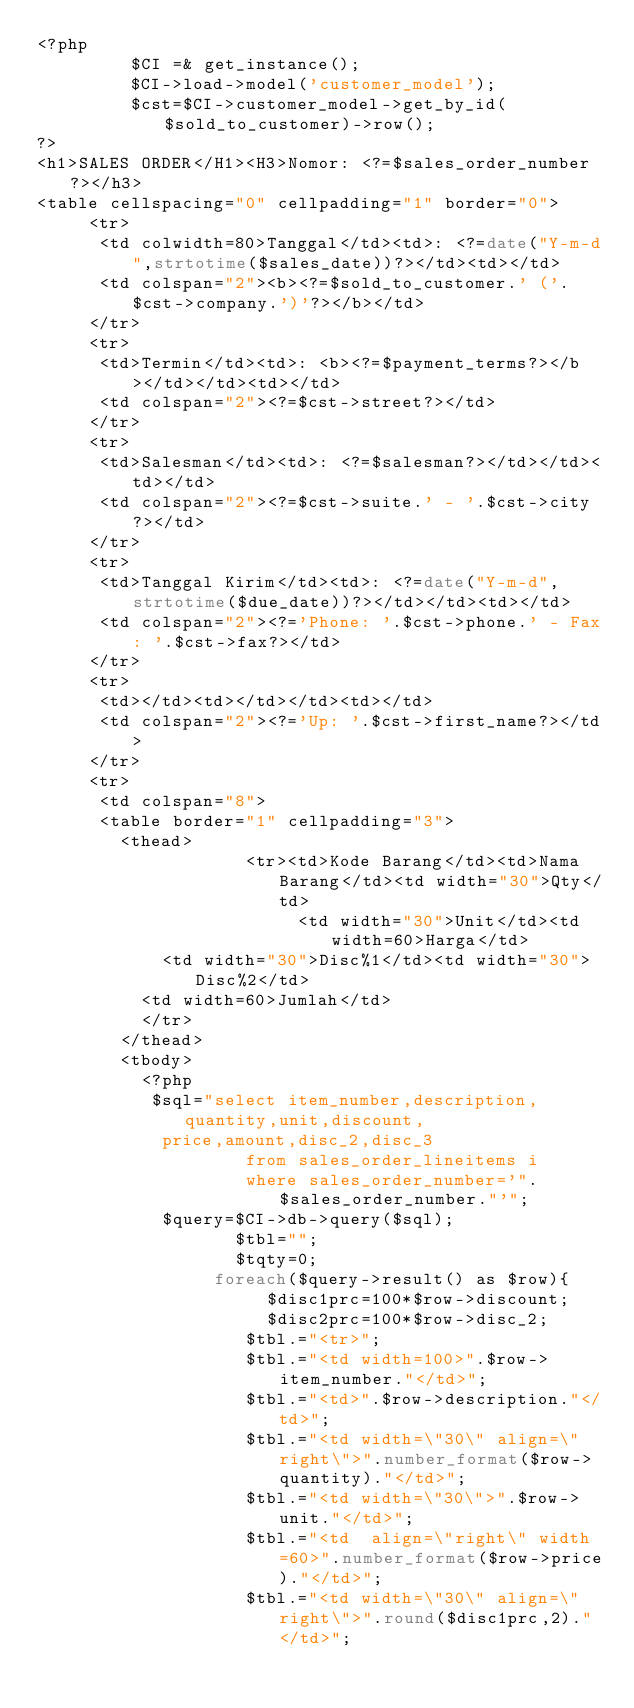Convert code to text. <code><loc_0><loc_0><loc_500><loc_500><_PHP_><?php
         $CI =& get_instance();
         $CI->load->model('customer_model');
         $cst=$CI->customer_model->get_by_id($sold_to_customer)->row();
?>
<h1>SALES ORDER</H1><H3>Nomor: <?=$sales_order_number?></h3>
<table cellspacing="0" cellpadding="1" border="0"> 
     <tr>
     	<td colwidth=80>Tanggal</td><td>: <?=date("Y-m-d",strtotime($sales_date))?></td><td></td>
     	<td colspan="2"><b><?=$sold_to_customer.' ('.$cst->company.')'?></b></td>
     </tr>
     <tr>
     	<td>Termin</td><td>: <b><?=$payment_terms?></b></td></td><td></td>
     	<td colspan="2"><?=$cst->street?></td>
     </tr>
     <tr>
     	<td>Salesman</td><td>: <?=$salesman?></td></td><td></td>
     	<td colspan="2"><?=$cst->suite.' - '.$cst->city?></td>
     </tr>
     <tr>
     	<td>Tanggal Kirim</td><td>: <?=date("Y-m-d",strtotime($due_date))?></td></td><td></td>
     	<td colspan="2"><?='Phone: '.$cst->phone.' - Fax: '.$cst->fax?></td>
     </tr>
     <tr>
     	<td></td><td></td></td><td></td>
     	<td colspan="2"><?='Up: '.$cst->first_name?></td>
     </tr>
     <tr>
     	<td colspan="8">
     	<table border="1" cellpadding="3">
     		<thead>
                    <tr><td>Kode Barang</td><td>Nama Barang</td><td width="30">Qty</td>
                         <td width="30">Unit</td><td width=60>Harga</td>
     				<td width="30">Disc%1</td><td width="30">Disc%2</td>
					<td width=60>Jumlah</td>
     			</tr>
     		</thead>
     		<tbody>
     			<?php
		       $sql="select item_number,description,quantity,unit,discount,
						price,amount,disc_2,disc_3
		                from sales_order_lineitems i
		                where sales_order_number='".$sales_order_number."'";
		        $query=$CI->db->query($sql);
                   $tbl="";
                   $tqty=0;
                 foreach($query->result() as $row){
                      $disc1prc=100*$row->discount;                      
                      $disc2prc=100*$row->disc_2;
                    $tbl.="<tr>";
                    $tbl.="<td width=100>".$row->item_number."</td>";
                    $tbl.="<td>".$row->description."</td>";
                    $tbl.="<td width=\"30\" align=\"right\">".number_format($row->quantity)."</td>";
                    $tbl.="<td width=\"30\">".$row->unit."</td>";
                    $tbl.="<td  align=\"right\" width=60>".number_format($row->price)."</td>";
                    $tbl.="<td width=\"30\" align=\"right\">".round($disc1prc,2)."</td>";</code> 